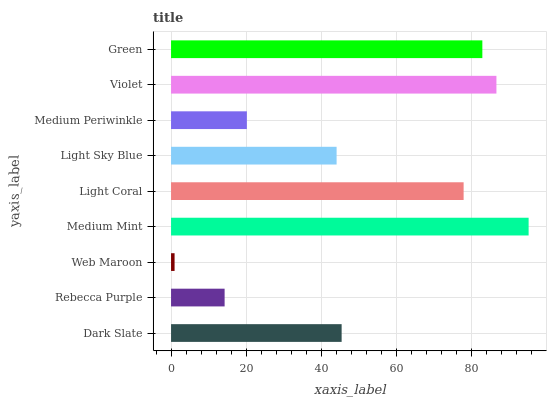Is Web Maroon the minimum?
Answer yes or no. Yes. Is Medium Mint the maximum?
Answer yes or no. Yes. Is Rebecca Purple the minimum?
Answer yes or no. No. Is Rebecca Purple the maximum?
Answer yes or no. No. Is Dark Slate greater than Rebecca Purple?
Answer yes or no. Yes. Is Rebecca Purple less than Dark Slate?
Answer yes or no. Yes. Is Rebecca Purple greater than Dark Slate?
Answer yes or no. No. Is Dark Slate less than Rebecca Purple?
Answer yes or no. No. Is Dark Slate the high median?
Answer yes or no. Yes. Is Dark Slate the low median?
Answer yes or no. Yes. Is Medium Periwinkle the high median?
Answer yes or no. No. Is Medium Periwinkle the low median?
Answer yes or no. No. 